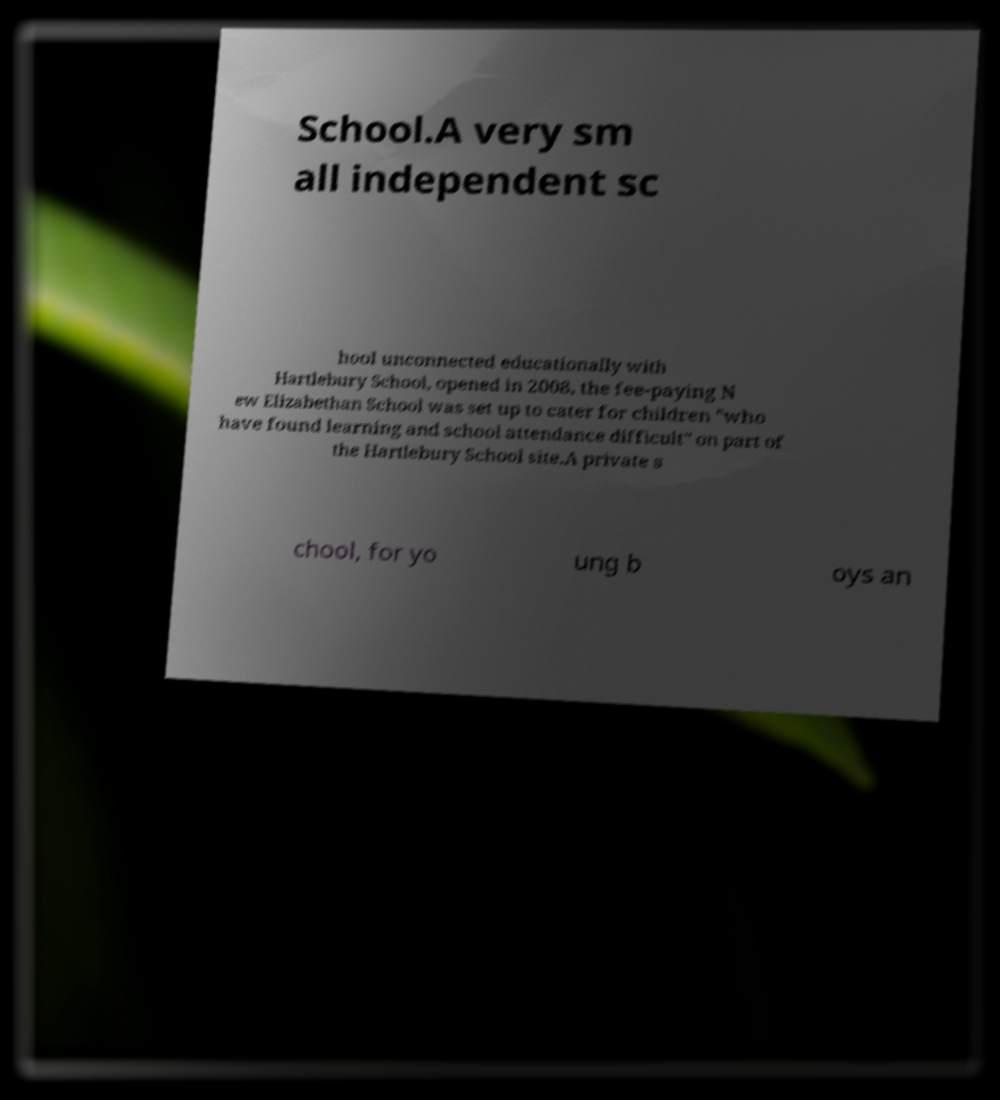Please identify and transcribe the text found in this image. School.A very sm all independent sc hool unconnected educationally with Hartlebury School, opened in 2008, the fee-paying N ew Elizabethan School was set up to cater for children "who have found learning and school attendance difficult" on part of the Hartlebury School site.A private s chool, for yo ung b oys an 